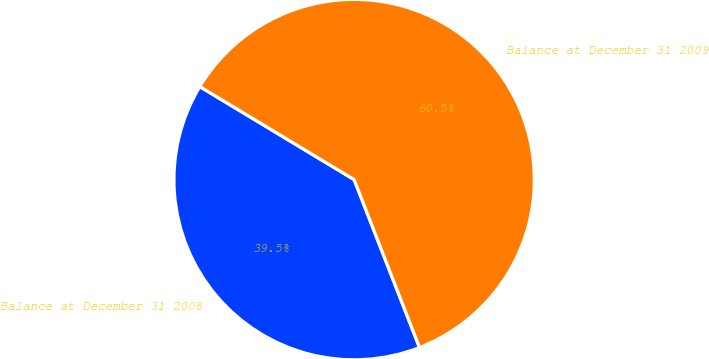<chart> <loc_0><loc_0><loc_500><loc_500><pie_chart><fcel>Balance at December 31 2008<fcel>Balance at December 31 2009<nl><fcel>39.54%<fcel>60.46%<nl></chart> 